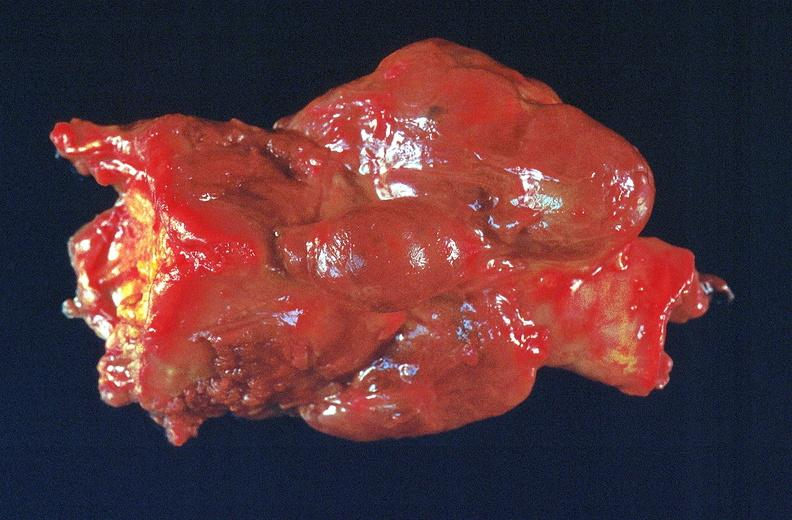s surface present?
Answer the question using a single word or phrase. No 